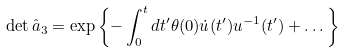Convert formula to latex. <formula><loc_0><loc_0><loc_500><loc_500>\det \hat { a } _ { 3 } = \exp \left \{ - \int _ { 0 } ^ { t } d t ^ { \prime } \theta ( 0 ) \dot { u } ( t ^ { \prime } ) u ^ { - 1 } ( t ^ { \prime } ) + \dots \right \}</formula> 